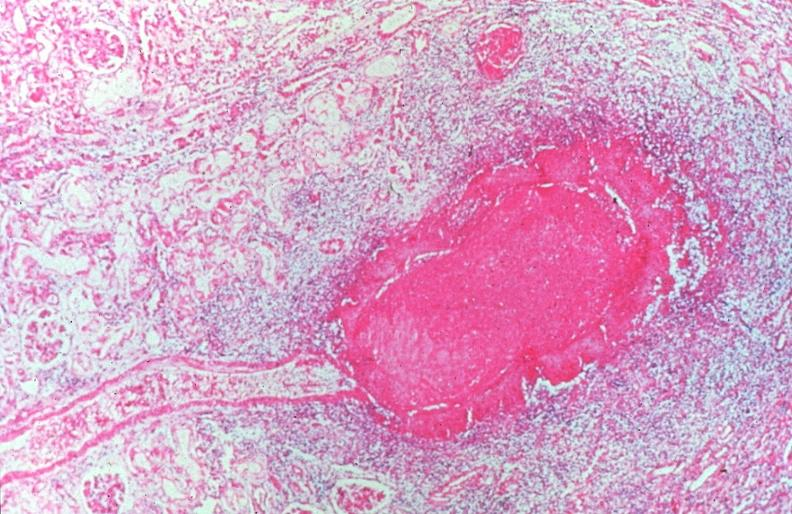what is present?
Answer the question using a single word or phrase. Vasculature 